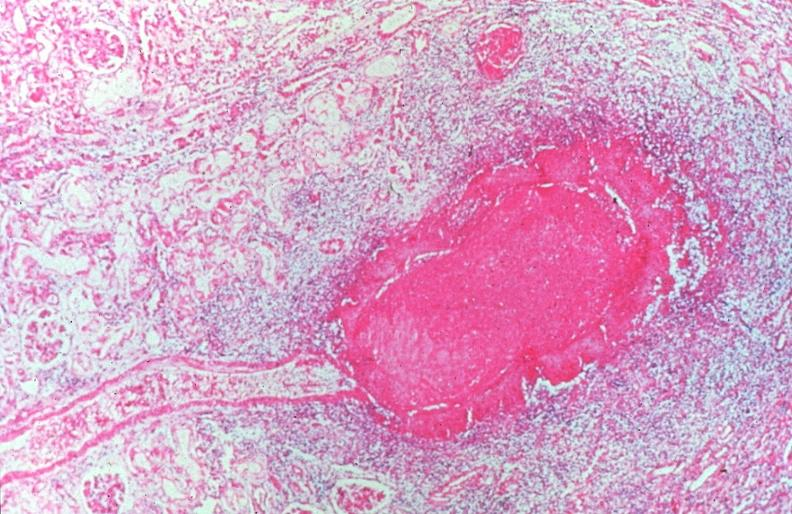what is present?
Answer the question using a single word or phrase. Vasculature 